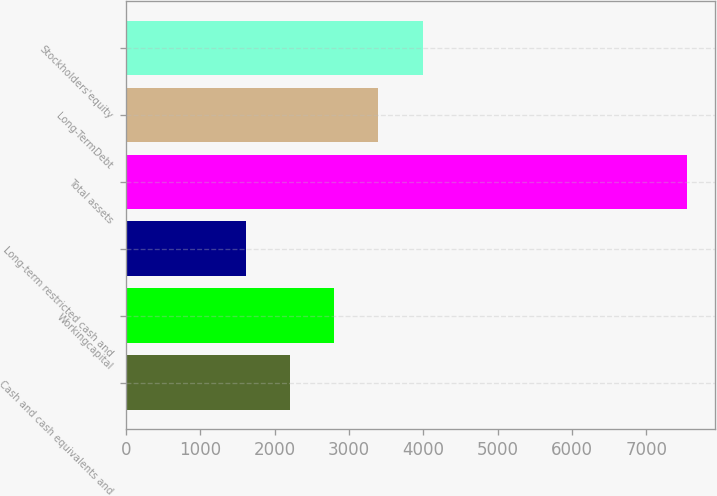Convert chart. <chart><loc_0><loc_0><loc_500><loc_500><bar_chart><fcel>Cash and cash equivalents and<fcel>Workingcapital<fcel>Long-term restricted cash and<fcel>Total assets<fcel>Long-TermDebt<fcel>Stockholders'equity<nl><fcel>2208.9<fcel>2802.8<fcel>1615<fcel>7554<fcel>3396.7<fcel>3990.6<nl></chart> 